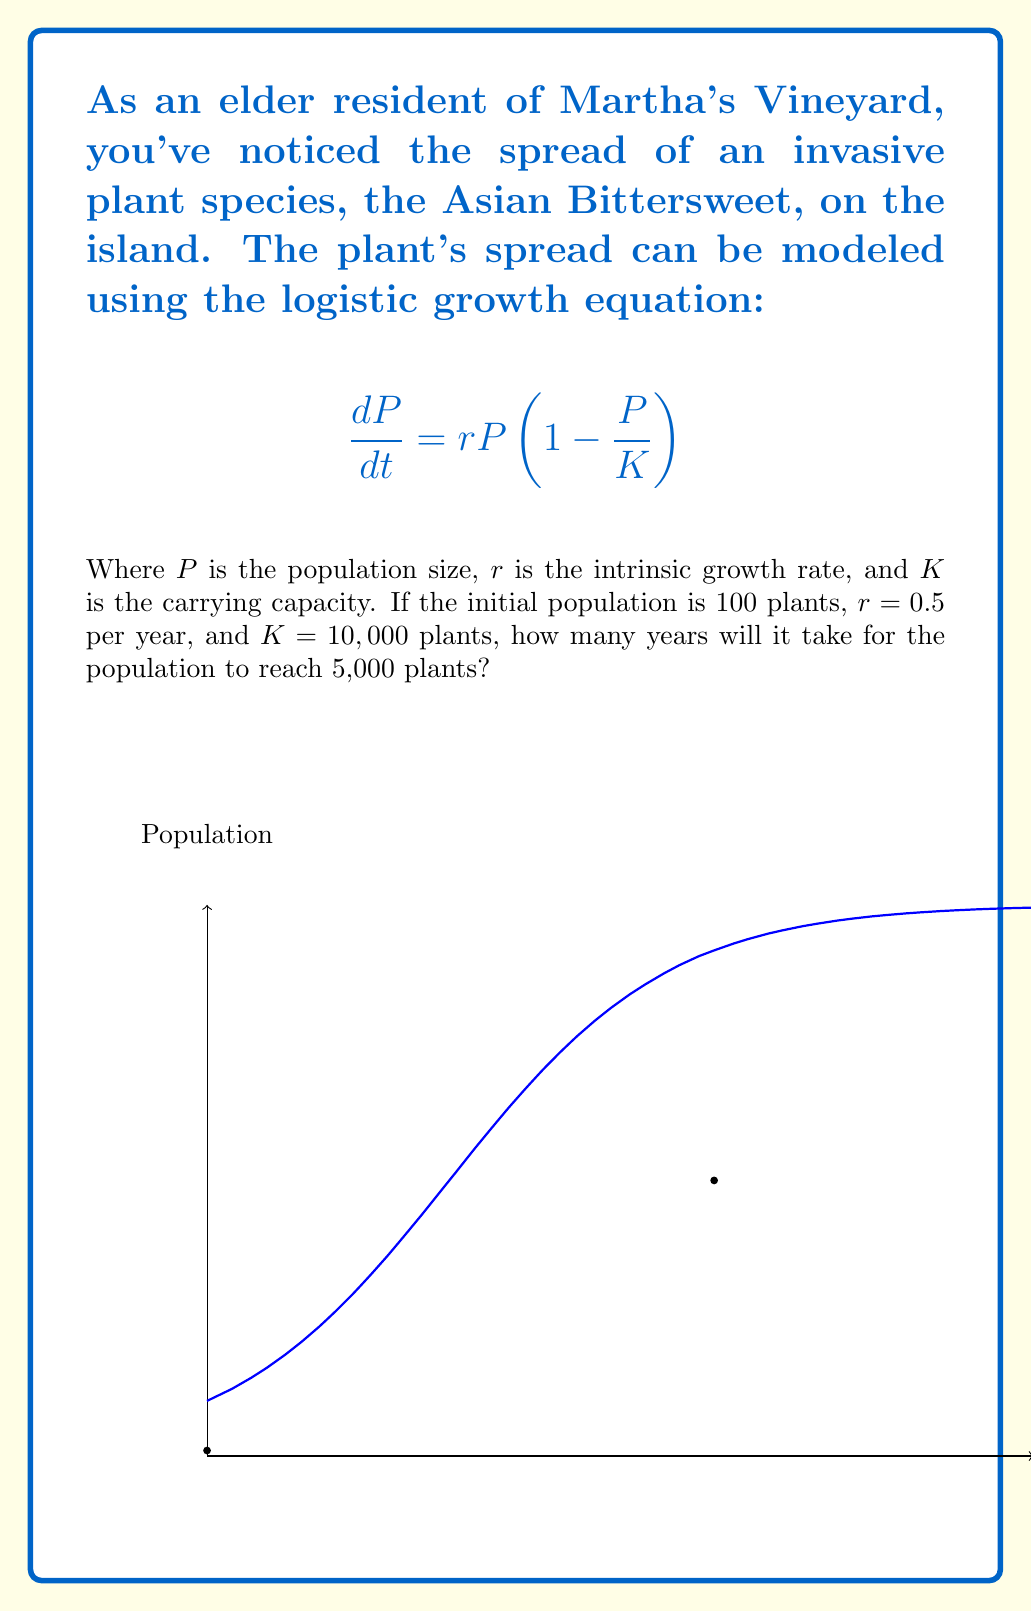Teach me how to tackle this problem. To solve this problem, we need to use the solution to the logistic growth equation:

$$P(t) = \frac{K}{1 + (\frac{K}{P_0} - 1)e^{-rt}}$$

Where $P_0$ is the initial population. Let's follow these steps:

1) Substitute the given values:
   $K = 10,000$, $P_0 = 100$, $r = 0.5$

2) We want to find $t$ when $P(t) = 5,000$. So, let's set up the equation:

   $$5000 = \frac{10000}{1 + (\frac{10000}{100} - 1)e^{-0.5t}}$$

3) Simplify:
   $$5000 = \frac{10000}{1 + 99e^{-0.5t}}$$

4) Multiply both sides by $(1 + 99e^{-0.5t})$:
   $$5000(1 + 99e^{-0.5t}) = 10000$$

5) Expand:
   $$5000 + 495000e^{-0.5t} = 10000$$

6) Subtract 5000 from both sides:
   $$495000e^{-0.5t} = 5000$$

7) Divide both sides by 495000:
   $$e^{-0.5t} = \frac{1}{99}$$

8) Take the natural log of both sides:
   $$-0.5t = \ln(\frac{1}{99}) = -\ln(99)$$

9) Divide both sides by -0.5:
   $$t = \frac{\ln(99)}{0.5} \approx 9.2$$

Therefore, it will take approximately 9.2 years for the population to reach 5,000 plants.
Answer: 9.2 years 